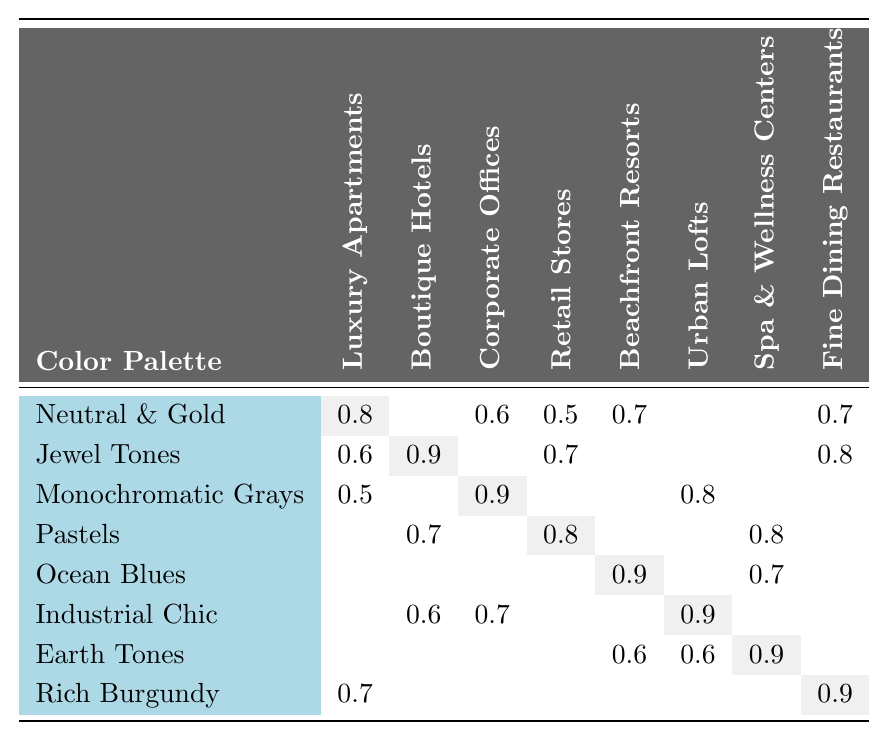What is the most preferred color palette for Luxury Apartments? The table indicates the highest preference score for Luxury Apartments is 0.8 for Neutral & Gold.
Answer: Neutral & Gold Which property type has the highest preference for Jewel Tones? Boutique Hotels shows the highest preference score of 0.9 for Jewel Tones.
Answer: Boutique Hotels Is there a color palette with the same preference score for both Boutique Hotels and Fine Dining Restaurants? Yes, Jewel Tones has a preference score of 0.8 for Fine Dining Restaurants and 0.9 for Boutique Hotels; however, they do not match.
Answer: No What is the preference score for Pastels in Retail Stores? The preference score for Pastels in Retail Stores is 0.8, as indicated in the table.
Answer: 0.8 Which two property types have a preference for both Rich Burgundy and Jewel Tones? Fine Dining Restaurants prefers Rich Burgundy (0.9) and Jewel Tones (0.8), while Jewel Tones (0.9) is the preference for Boutique Hotels.
Answer: Fine Dining Restaurants and Boutique Hotels How many property types prefer Ocean Blues? Ocean Blues is preferred by two property types: Beachfront Resorts (0.9) and Spa & Wellness Centers (0.7).
Answer: Two What is the total preference score for Industrial Chic across all property types? The preference scores for Industrial Chic are: Boutique Hotels (0.6), Corporate Offices (0.7), and Urban Lofts (0.9). The total calculated score is 0.6 + 0.7 + 0.9 = 2.2.
Answer: 2.2 Which color palette is preferred the most by Spa & Wellness Centers? The highest preference score for Spa & Wellness Centers is 0.9 for Earth Tones.
Answer: Earth Tones Are there any property types that have the same preference score for Neutral & Gold? Yes, both Luxury Apartments (0.8) and Beachfront Resorts (0.7) have preferences for Neutral & Gold, but only Luxury Apartments have the same score with Fine Dining Restaurants (0.7).
Answer: Yes What color palette has the lowest preference across all property types? The color palette with the lowest scores includes Monochromatic Grays with a score of 0.5 for Luxury Apartments and 0.5 for Retail Stores.
Answer: Monochromatic Grays 